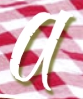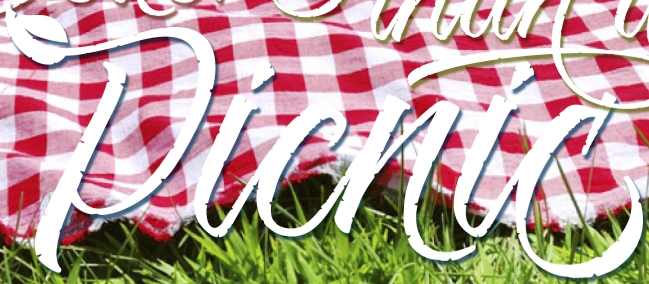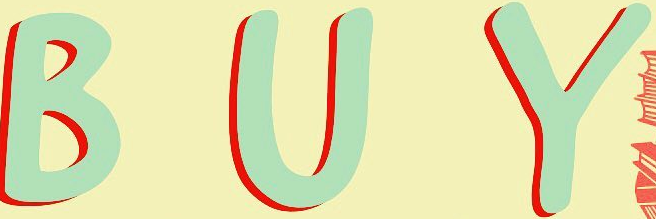Read the text content from these images in order, separated by a semicolon. a; Picnic; BUY 